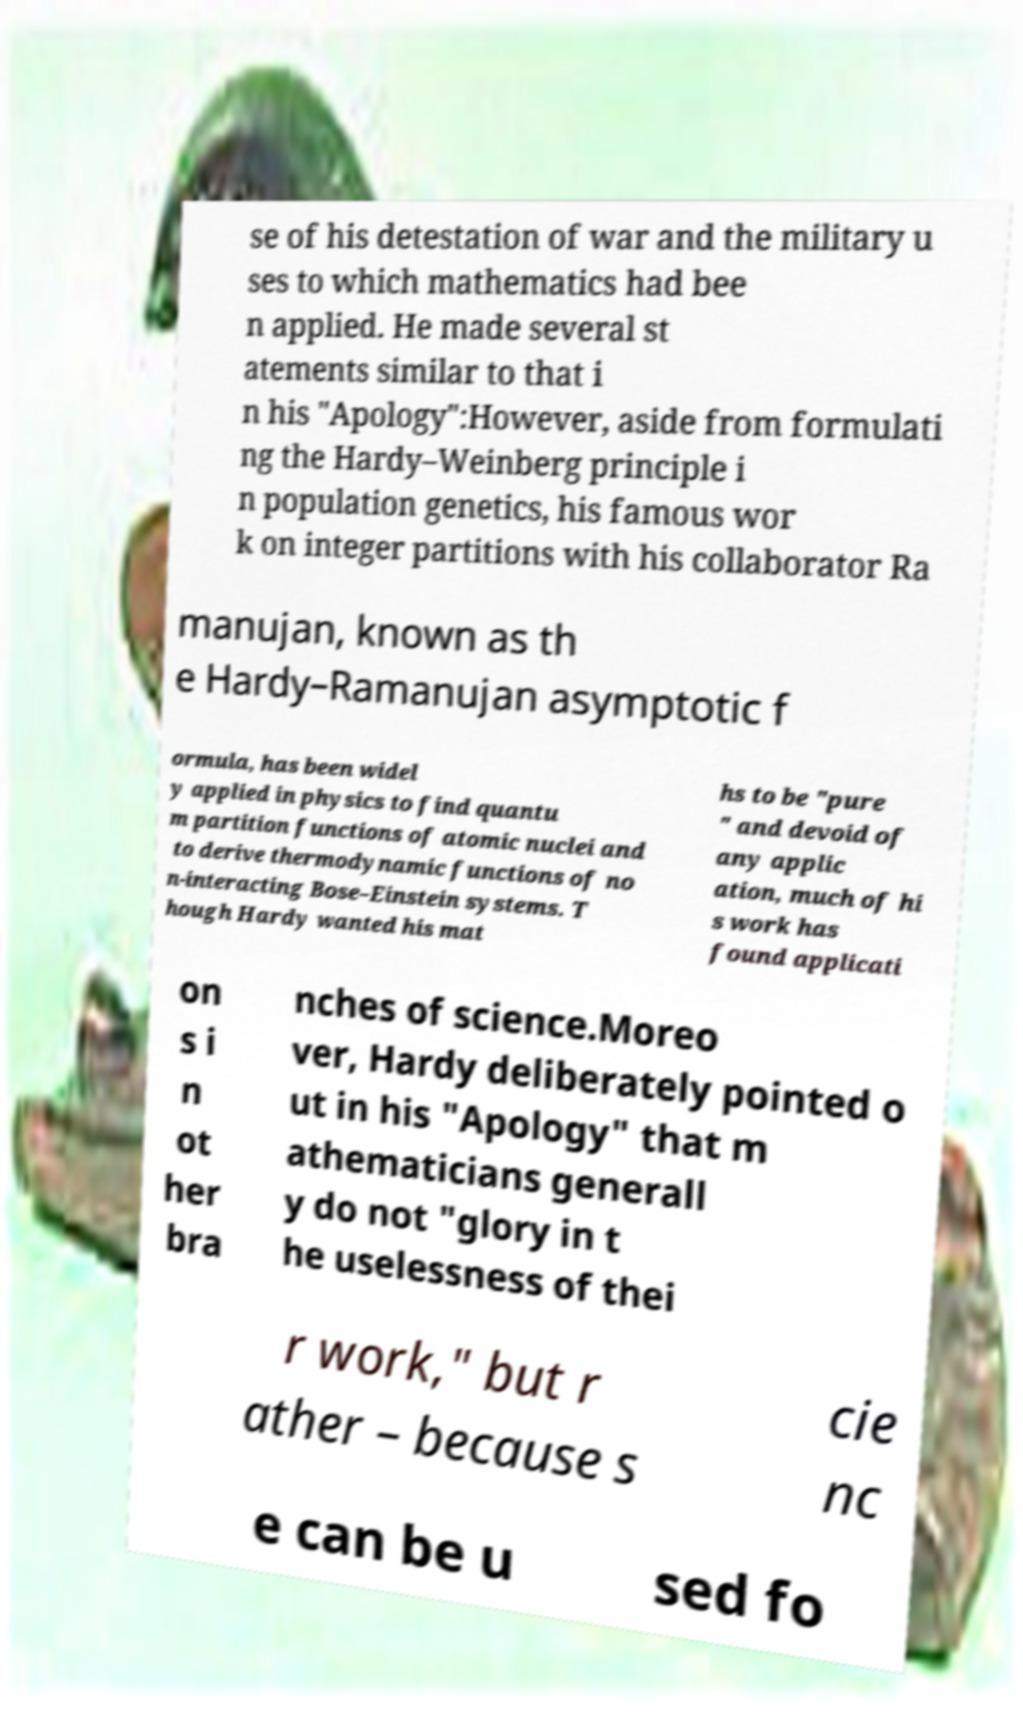What messages or text are displayed in this image? I need them in a readable, typed format. se of his detestation of war and the military u ses to which mathematics had bee n applied. He made several st atements similar to that i n his "Apology":However, aside from formulati ng the Hardy–Weinberg principle i n population genetics, his famous wor k on integer partitions with his collaborator Ra manujan, known as th e Hardy–Ramanujan asymptotic f ormula, has been widel y applied in physics to find quantu m partition functions of atomic nuclei and to derive thermodynamic functions of no n-interacting Bose–Einstein systems. T hough Hardy wanted his mat hs to be "pure " and devoid of any applic ation, much of hi s work has found applicati on s i n ot her bra nches of science.Moreo ver, Hardy deliberately pointed o ut in his "Apology" that m athematicians generall y do not "glory in t he uselessness of thei r work," but r ather – because s cie nc e can be u sed fo 